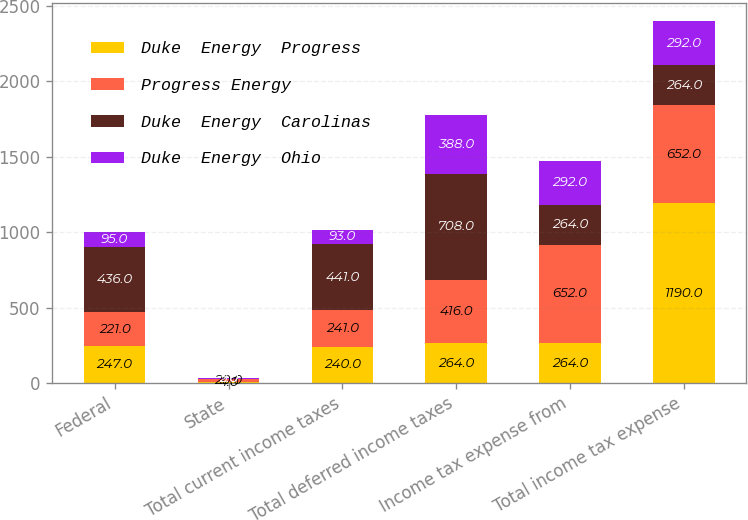Convert chart to OTSL. <chart><loc_0><loc_0><loc_500><loc_500><stacked_bar_chart><ecel><fcel>Federal<fcel>State<fcel>Total current income taxes<fcel>Total deferred income taxes<fcel>Income tax expense from<fcel>Total income tax expense<nl><fcel>Duke  Energy  Progress<fcel>247<fcel>4<fcel>240<fcel>264<fcel>264<fcel>1190<nl><fcel>Progress Energy<fcel>221<fcel>20<fcel>241<fcel>416<fcel>652<fcel>652<nl><fcel>Duke  Energy  Carolinas<fcel>436<fcel>5<fcel>441<fcel>708<fcel>264<fcel>264<nl><fcel>Duke  Energy  Ohio<fcel>95<fcel>2<fcel>93<fcel>388<fcel>292<fcel>292<nl></chart> 